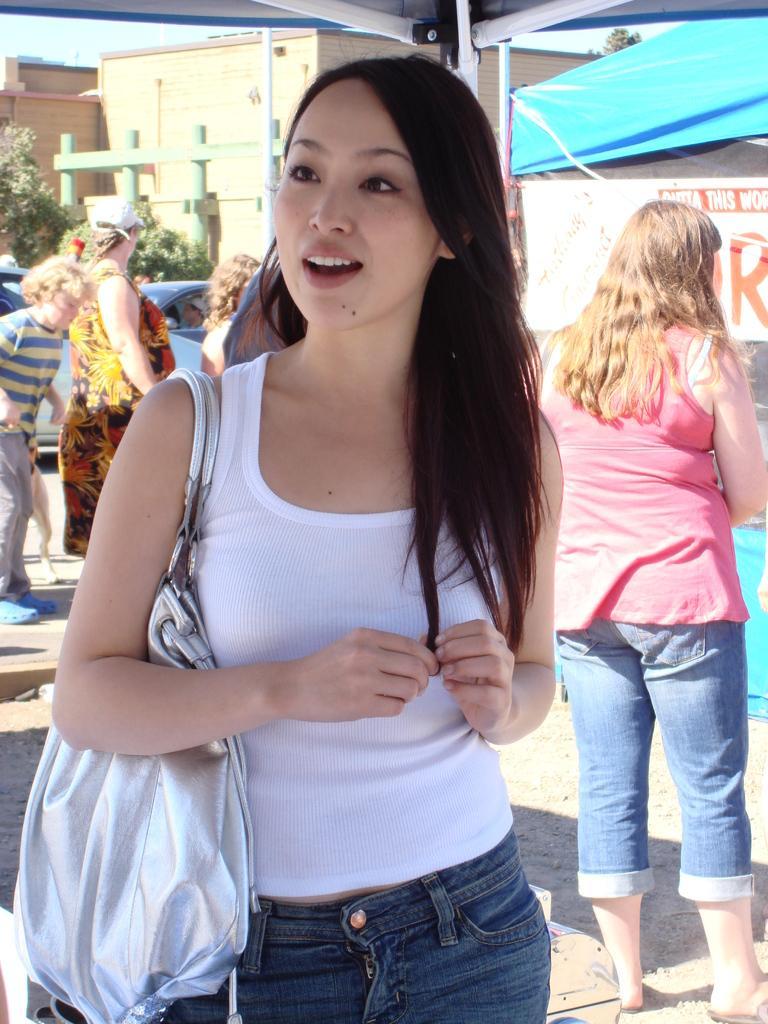Can you describe this image briefly? In this image, there is an outside view. There are group of people standing and wearing clothes. There is a building at the top of the image. 